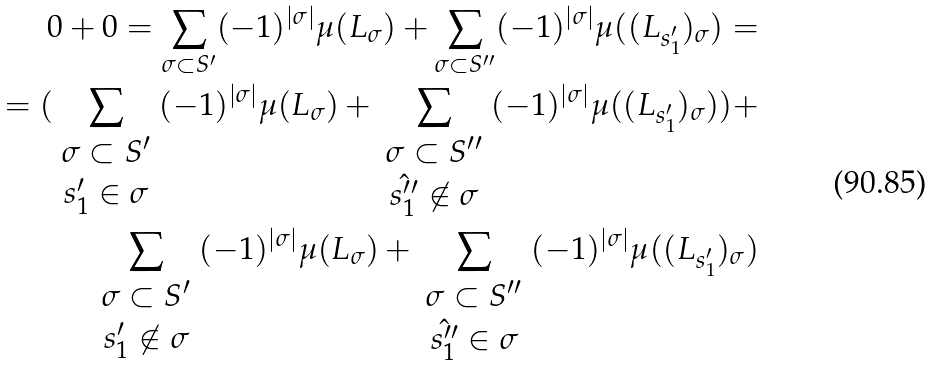<formula> <loc_0><loc_0><loc_500><loc_500>0 + 0 = \sum _ { \sigma \subset S ^ { \prime } } ( - 1 ) ^ { | \sigma | } \mu ( L _ { \sigma } ) + \sum _ { \sigma \subset S ^ { \prime \prime } } ( - 1 ) ^ { | \sigma | } \mu ( ( L _ { s _ { 1 } ^ { \prime } } ) _ { \sigma } ) = \\ = ( \sum _ { \begin{array} { c } \sigma \subset S ^ { \prime } \\ s _ { 1 } ^ { \prime } \in \sigma \end{array} } ( - 1 ) ^ { | \sigma | } \mu ( L _ { \sigma } ) + \sum _ { \begin{array} { c } \sigma \subset S ^ { \prime \prime } \\ \hat { s _ { 1 } ^ { \prime \prime } } \not \in \sigma \end{array} } ( - 1 ) ^ { | \sigma | } \mu ( ( L _ { s _ { 1 } ^ { \prime } } ) _ { \sigma } ) ) + \\ \sum _ { \begin{array} { c } \sigma \subset S ^ { \prime } \\ s _ { 1 } ^ { \prime } \not \in \sigma \end{array} } ( - 1 ) ^ { | \sigma | } \mu ( L _ { \sigma } ) + \sum _ { \begin{array} { c } \sigma \subset S ^ { \prime \prime } \\ \hat { s _ { 1 } ^ { \prime \prime } } \in \sigma \end{array} } ( - 1 ) ^ { | \sigma | } \mu ( ( L _ { s _ { 1 } ^ { \prime } } ) _ { \sigma } ) \\</formula> 